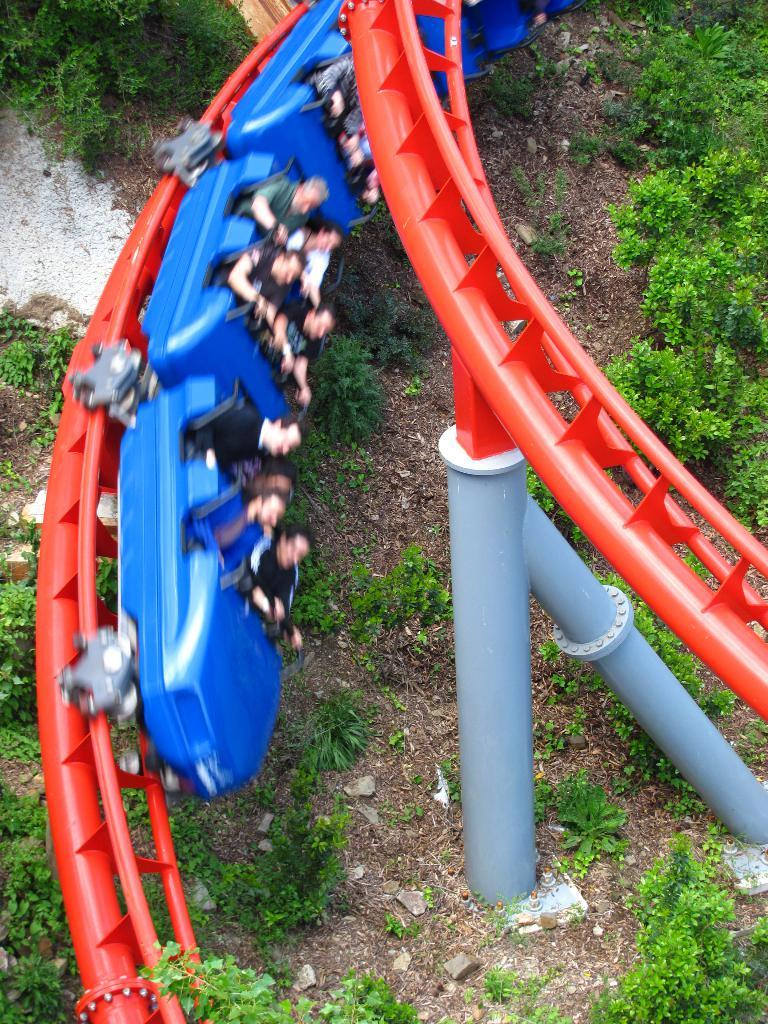Who is present in the image? There are people in the image. What are the people doing in the image? The people are taking a ride. What can be seen in the background or surrounding the ride? There are plants around the ride. How many attempts did the window make to join the ride in the image? There is no window present in the image, so it cannot make any attempts to join the ride. 